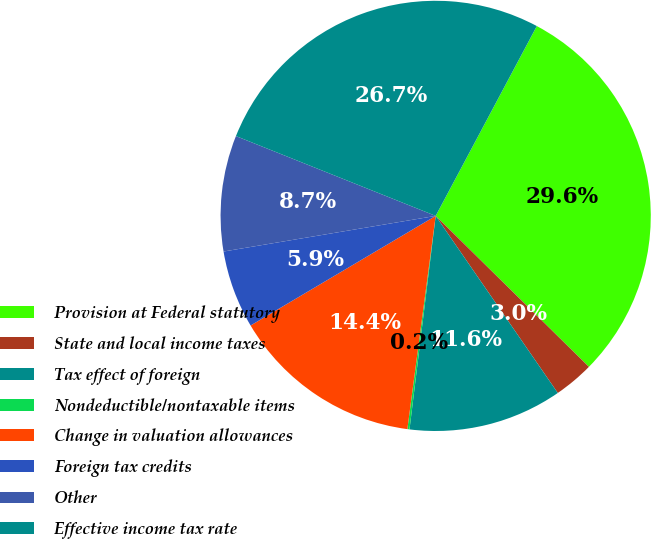Convert chart to OTSL. <chart><loc_0><loc_0><loc_500><loc_500><pie_chart><fcel>Provision at Federal statutory<fcel>State and local income taxes<fcel>Tax effect of foreign<fcel>Nondeductible/nontaxable items<fcel>Change in valuation allowances<fcel>Foreign tax credits<fcel>Other<fcel>Effective income tax rate<nl><fcel>29.59%<fcel>3.01%<fcel>11.55%<fcel>0.16%<fcel>14.39%<fcel>5.86%<fcel>8.7%<fcel>26.74%<nl></chart> 